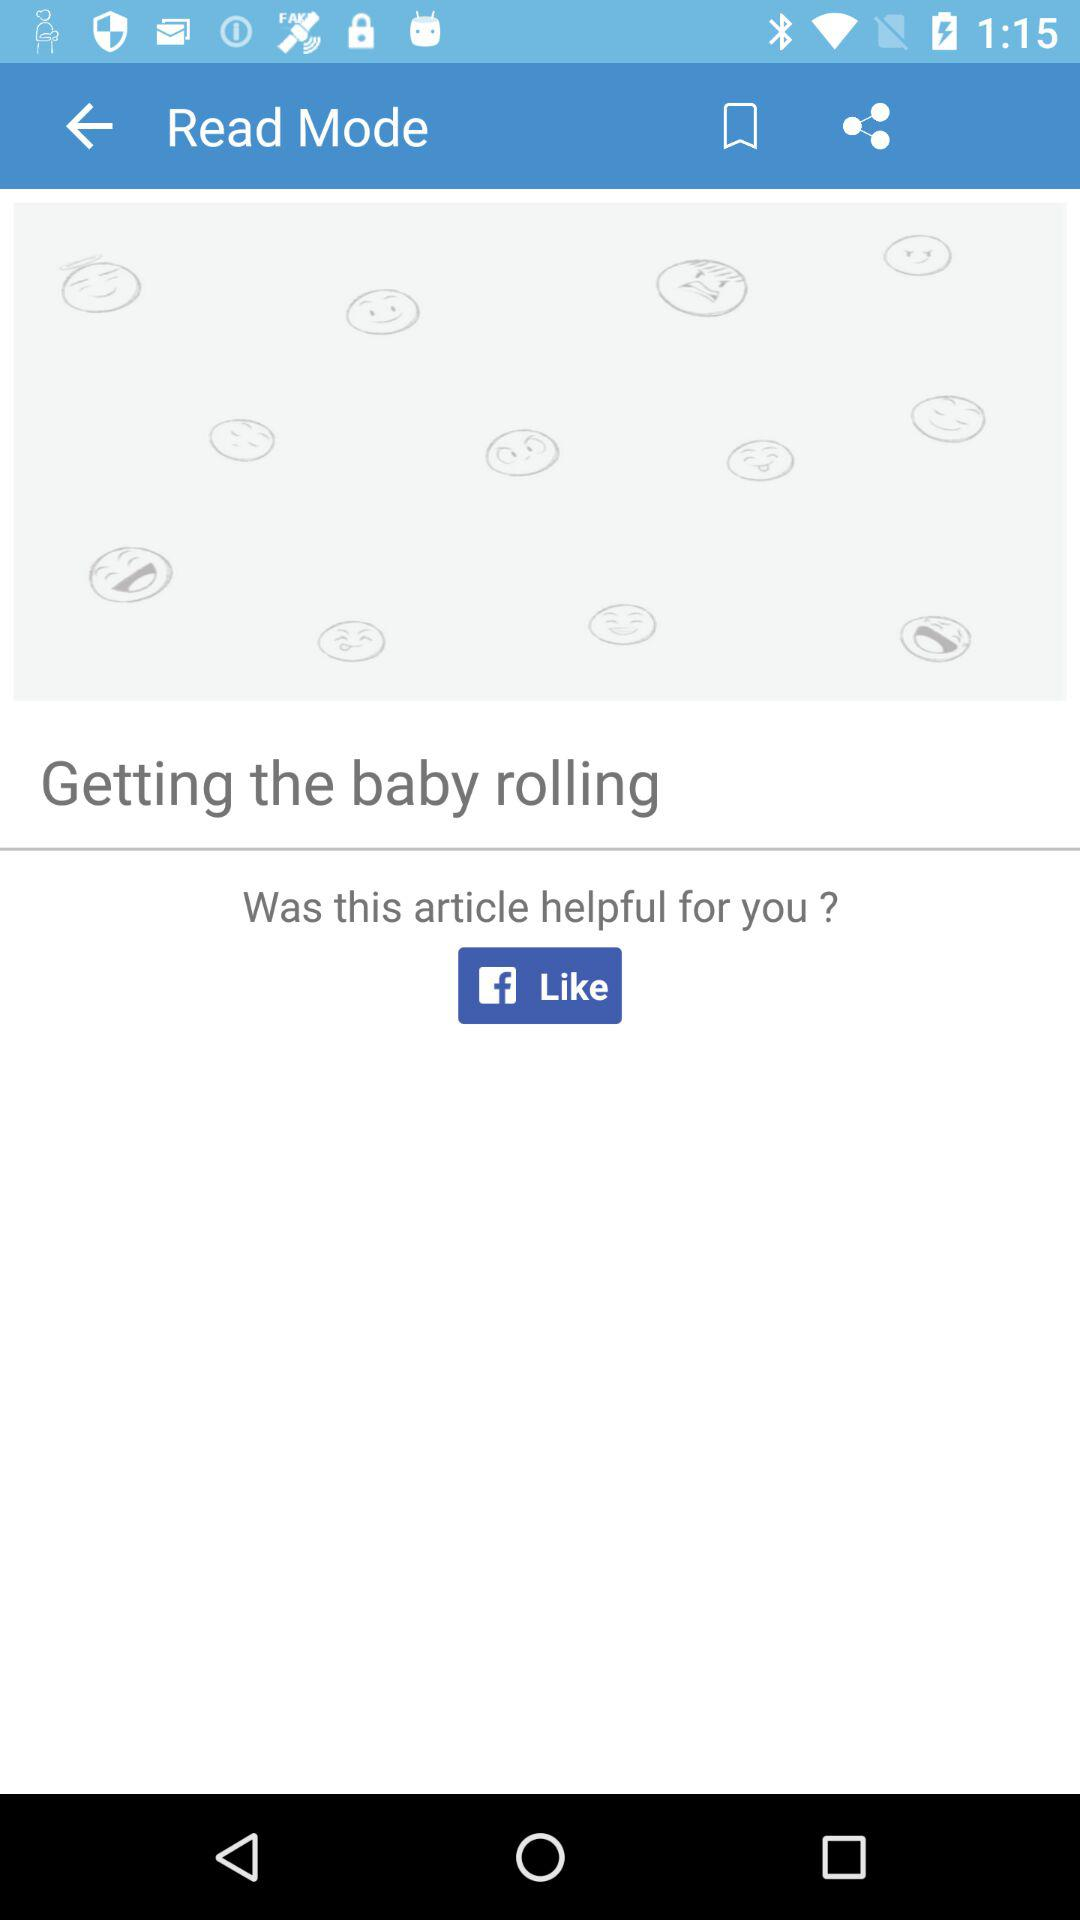What is the mode of the application displayed? The displayed mode of the application is "Read Mode". 